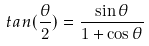Convert formula to latex. <formula><loc_0><loc_0><loc_500><loc_500>t a n ( \frac { \theta } { 2 } ) = \frac { \sin \theta } { 1 + \cos \theta }</formula> 